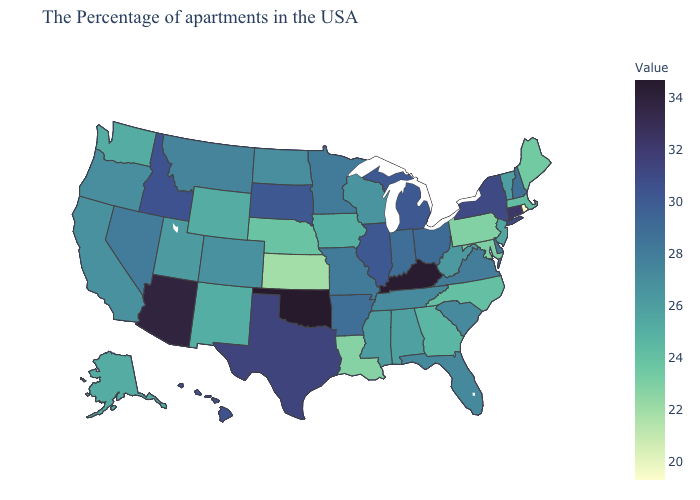Does Ohio have the lowest value in the MidWest?
Short answer required. No. Does California have the lowest value in the West?
Concise answer only. No. Which states have the lowest value in the Northeast?
Short answer required. Rhode Island. 